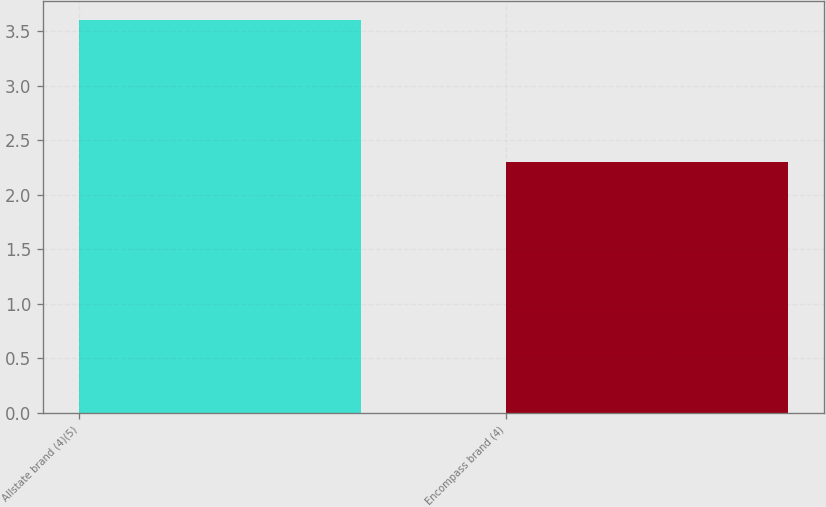Convert chart to OTSL. <chart><loc_0><loc_0><loc_500><loc_500><bar_chart><fcel>Allstate brand (4)(5)<fcel>Encompass brand (4)<nl><fcel>3.6<fcel>2.3<nl></chart> 